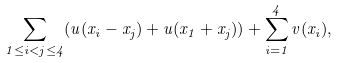<formula> <loc_0><loc_0><loc_500><loc_500>\sum _ { 1 \leq i < j \leq 4 } ( u ( x _ { i } - x _ { j } ) + u ( x _ { 1 } + x _ { j } ) ) + \sum _ { i = 1 } ^ { 4 } v ( x _ { i } ) ,</formula> 